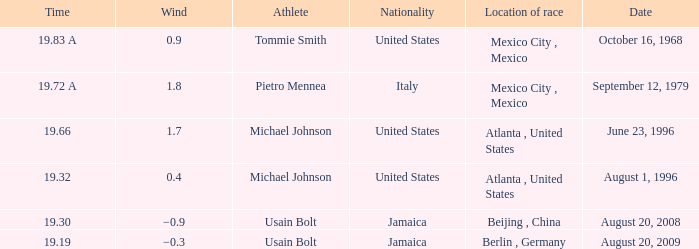Who's the athlete with a wind of 1.7 and from the United States? Michael Johnson. 